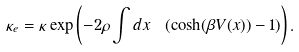<formula> <loc_0><loc_0><loc_500><loc_500>\kappa _ { e } = \kappa \exp \left ( - 2 \rho \int d x \ \left ( \cosh ( \beta V ( x ) ) - 1 \right ) \right ) .</formula> 